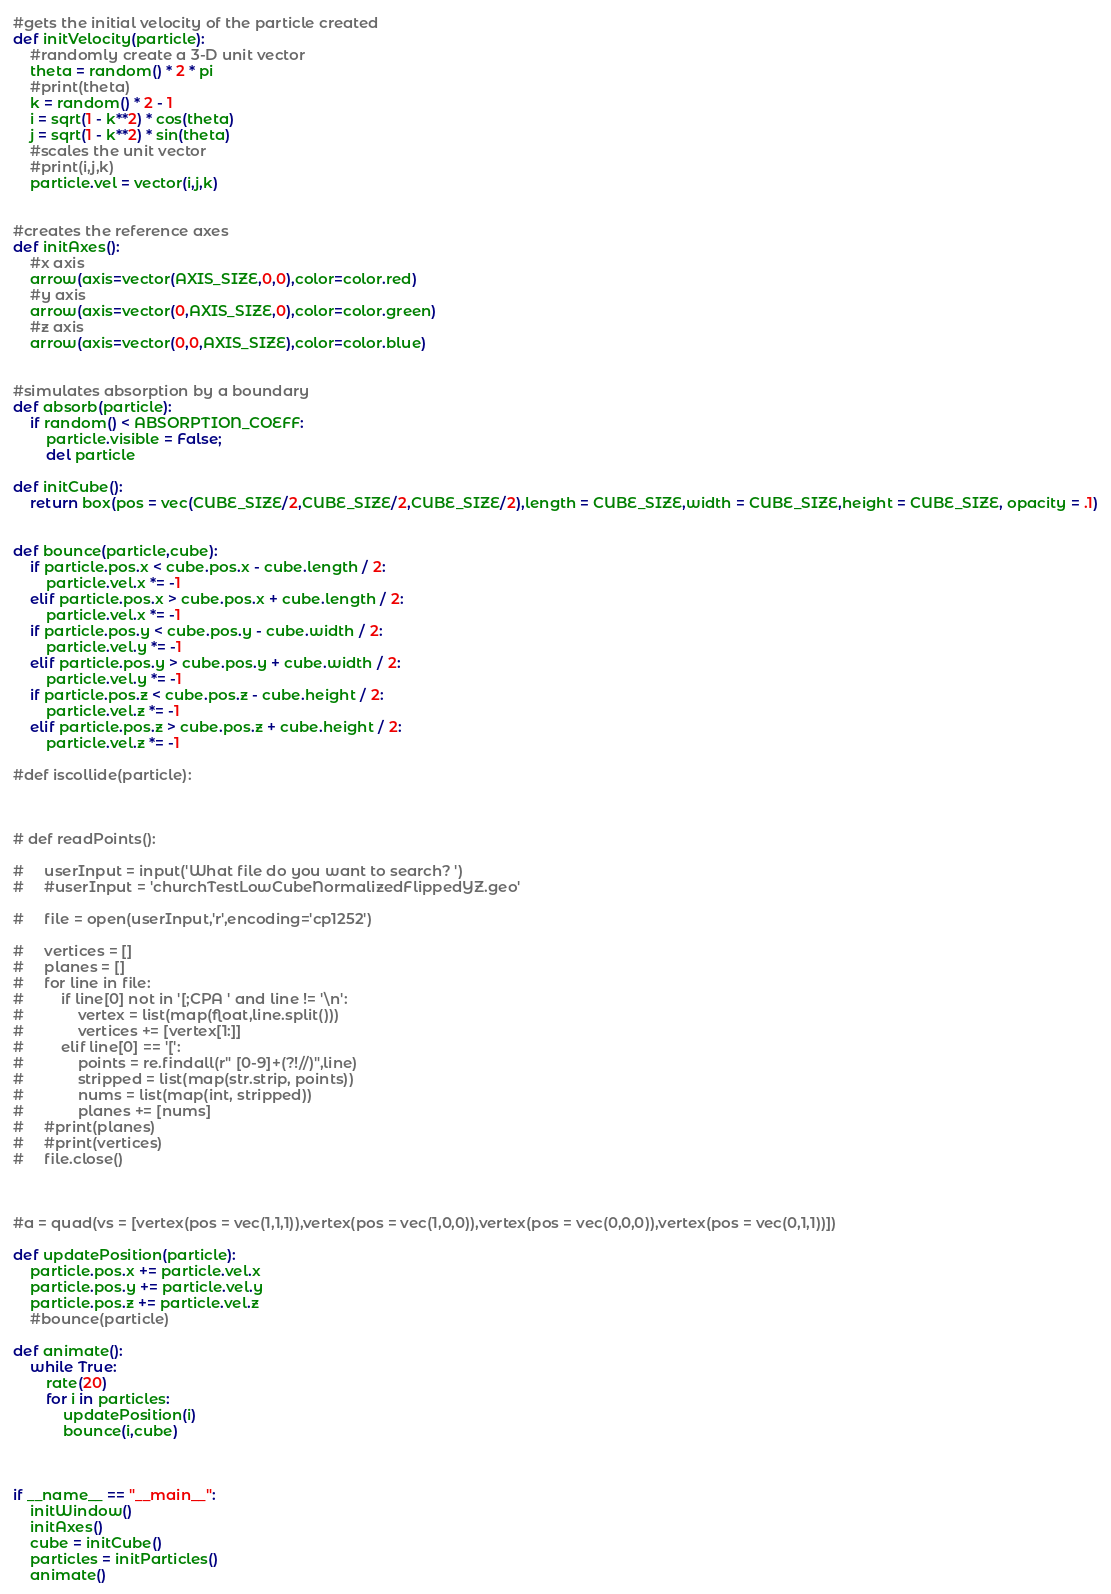<code> <loc_0><loc_0><loc_500><loc_500><_Python_>

#gets the initial velocity of the particle created
def initVelocity(particle):
    #randomly create a 3-D unit vector
    theta = random() * 2 * pi
    #print(theta)
    k = random() * 2 - 1
    i = sqrt(1 - k**2) * cos(theta)
    j = sqrt(1 - k**2) * sin(theta)
    #scales the unit vector
    #print(i,j,k)
    particle.vel = vector(i,j,k)


#creates the reference axes
def initAxes():
    #x axis
    arrow(axis=vector(AXIS_SIZE,0,0),color=color.red)
    #y axis
    arrow(axis=vector(0,AXIS_SIZE,0),color=color.green)
    #z axis
    arrow(axis=vector(0,0,AXIS_SIZE),color=color.blue)


#simulates absorption by a boundary
def absorb(particle):
    if random() < ABSORPTION_COEFF:
        particle.visible = False;
        del particle

def initCube():
    return box(pos = vec(CUBE_SIZE/2,CUBE_SIZE/2,CUBE_SIZE/2),length = CUBE_SIZE,width = CUBE_SIZE,height = CUBE_SIZE, opacity = .1)


def bounce(particle,cube):
    if particle.pos.x < cube.pos.x - cube.length / 2:
        particle.vel.x *= -1
    elif particle.pos.x > cube.pos.x + cube.length / 2:
        particle.vel.x *= -1
    if particle.pos.y < cube.pos.y - cube.width / 2:
        particle.vel.y *= -1
    elif particle.pos.y > cube.pos.y + cube.width / 2:
        particle.vel.y *= -1
    if particle.pos.z < cube.pos.z - cube.height / 2:
        particle.vel.z *= -1
    elif particle.pos.z > cube.pos.z + cube.height / 2:
        particle.vel.z *= -1

#def iscollide(particle):



# def readPoints():

#     userInput = input('What file do you want to search? ')
#     #userInput = 'churchTestLowCubeNormalizedFlippedYZ.geo'

#     file = open(userInput,'r',encoding='cp1252')
    
#     vertices = []
#     planes = []
#     for line in file:
#         if line[0] not in '[;CPA ' and line != '\n':
#             vertex = list(map(float,line.split()))
#             vertices += [vertex[1:]]
#         elif line[0] == '[':
#             points = re.findall(r" [0-9]+(?!//)",line)
#             stripped = list(map(str.strip, points))
#             nums = list(map(int, stripped))
#             planes += [nums]
#     #print(planes)
#     #print(vertices)
#     file.close()



#a = quad(vs = [vertex(pos = vec(1,1,1)),vertex(pos = vec(1,0,0)),vertex(pos = vec(0,0,0)),vertex(pos = vec(0,1,1))])

def updatePosition(particle):
    particle.pos.x += particle.vel.x
    particle.pos.y += particle.vel.y
    particle.pos.z += particle.vel.z
    #bounce(particle)

def animate():
    while True:
        rate(20)
        for i in particles:
            updatePosition(i)
            bounce(i,cube)



if __name__ == "__main__":
    initWindow()
    initAxes()
    cube = initCube()
    particles = initParticles()
    animate()</code> 